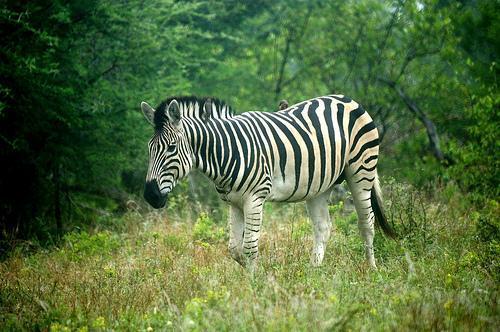How many zebras are there?
Give a very brief answer. 1. 